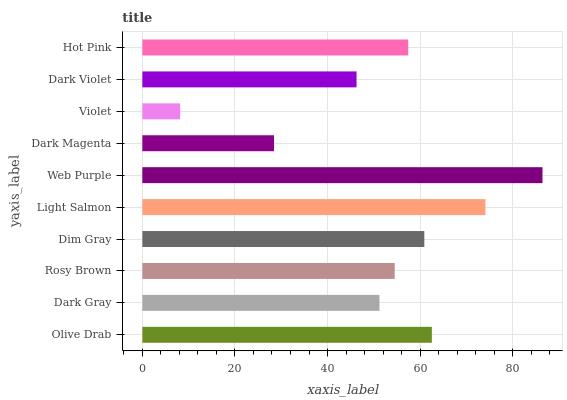Is Violet the minimum?
Answer yes or no. Yes. Is Web Purple the maximum?
Answer yes or no. Yes. Is Dark Gray the minimum?
Answer yes or no. No. Is Dark Gray the maximum?
Answer yes or no. No. Is Olive Drab greater than Dark Gray?
Answer yes or no. Yes. Is Dark Gray less than Olive Drab?
Answer yes or no. Yes. Is Dark Gray greater than Olive Drab?
Answer yes or no. No. Is Olive Drab less than Dark Gray?
Answer yes or no. No. Is Hot Pink the high median?
Answer yes or no. Yes. Is Rosy Brown the low median?
Answer yes or no. Yes. Is Light Salmon the high median?
Answer yes or no. No. Is Dark Gray the low median?
Answer yes or no. No. 